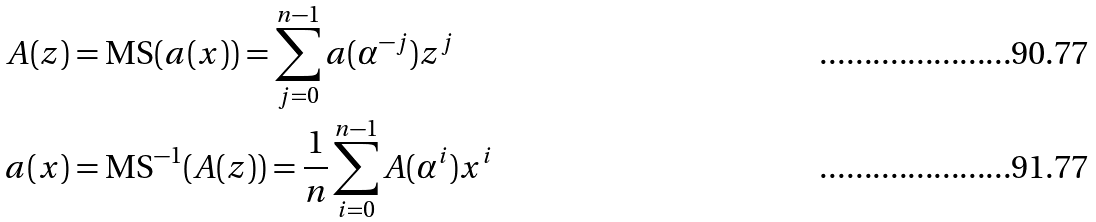Convert formula to latex. <formula><loc_0><loc_0><loc_500><loc_500>A ( z ) & = \text {MS} ( a ( x ) ) = \sum _ { j = 0 } ^ { n - 1 } a ( \alpha ^ { - j } ) z ^ { j } \\ a ( x ) & = \text {MS} ^ { - 1 } ( A ( z ) ) = \frac { 1 } { n } \sum _ { i = 0 } ^ { n - 1 } A ( \alpha ^ { i } ) x ^ { i }</formula> 